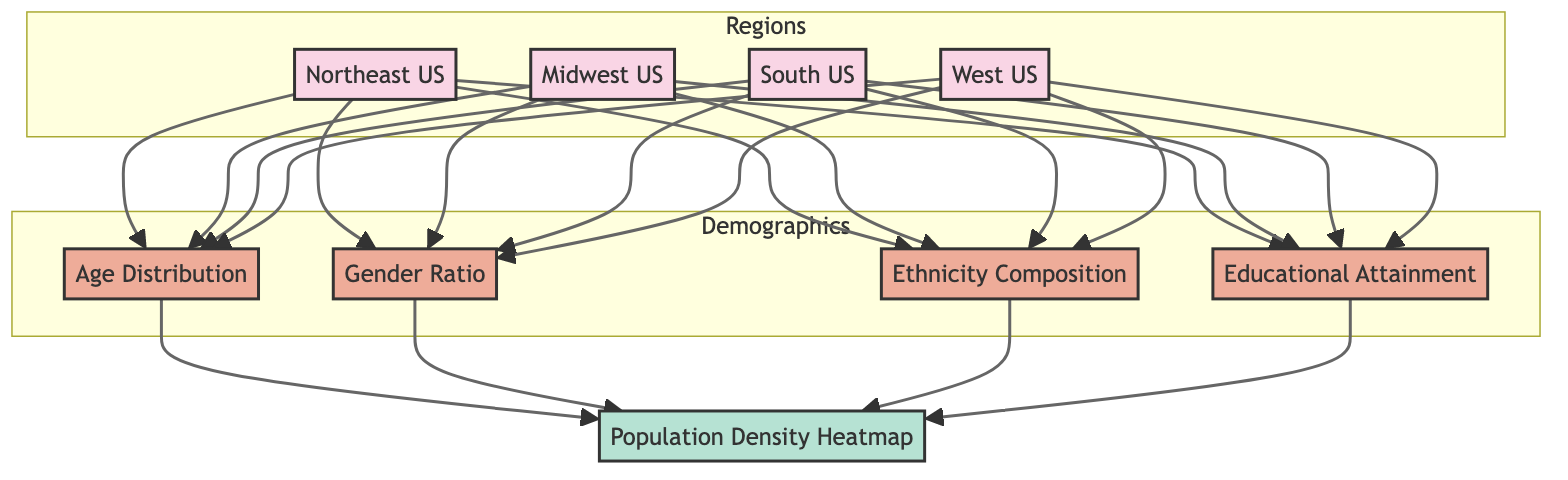What are the four regions depicted in the diagram? The diagram lists four regions: Northeast US, Midwest US, South US, and West US. These are shown as separate nodes in the "Regions" subgraph.
Answer: Northeast US, Midwest US, South US, West US How many demographic categories are represented? There are four demographic categories represented: Age Distribution, Gender Ratio, Ethnicity Composition, and Educational Attainment. This is evident as there are four connected nodes in the "Demographics" subgraph.
Answer: Four Which demographic category directly connects to the heatmap? All four demographic categories connect to the heatmap, as indicated by the connections from each demographic node to the Heatmap node.
Answer: All Which region has a connection to the Gender Ratio demographic? All four regions (Northeast US, Midwest US, South US, and West US) have a connection to the Gender Ratio demographic, as each region links to this demographic node.
Answer: All regions What color represents the heatmap in the diagram? The heatmap is represented in a light green color (#b6e2d3), as indicated by the classDef for the Heatmap node.
Answer: Light green What can be inferred about the relationship between demographic categories and regions? Each demographic category is linked to all four regions, suggesting that demographic data is collected for all regions equally. This relationship shows a comprehensive view of veteran demographics across different areas.
Answer: All regions share demographic categories Which demographic category might provide insights on educational support for veterans? The educational attainment demographic category would provide insights on the educational support needed for veterans, as it focuses on the educational level of the population.
Answer: Educational Attainment How does the structure of the diagram enhance understanding of veteran demographics? The diagram's structure allows viewers to see direct connections between regions and demographic categories, facilitating an understanding of how demographics vary across regions and how they contribute to the overall population density represented in the heatmap.
Answer: Clear relationships illustrate demographic variations 